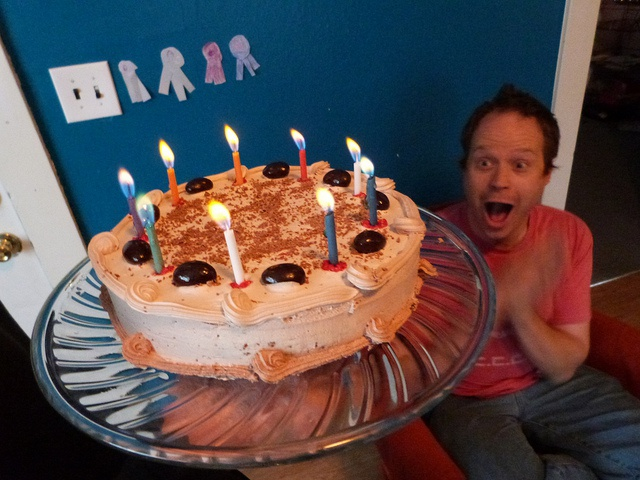Describe the objects in this image and their specific colors. I can see cake in darkblue, tan, brown, and salmon tones and people in darkblue, black, maroon, and brown tones in this image. 